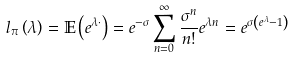Convert formula to latex. <formula><loc_0><loc_0><loc_500><loc_500>l _ { \pi } \left ( \lambda \right ) = \mathbb { E } \left ( e ^ { \lambda \cdot } \right ) = e ^ { - \sigma } \sum _ { n = 0 } ^ { \infty } \frac { \sigma ^ { n } } { n ! } e ^ { \lambda n } = e ^ { \sigma \left ( e ^ { \lambda } - 1 \right ) }</formula> 